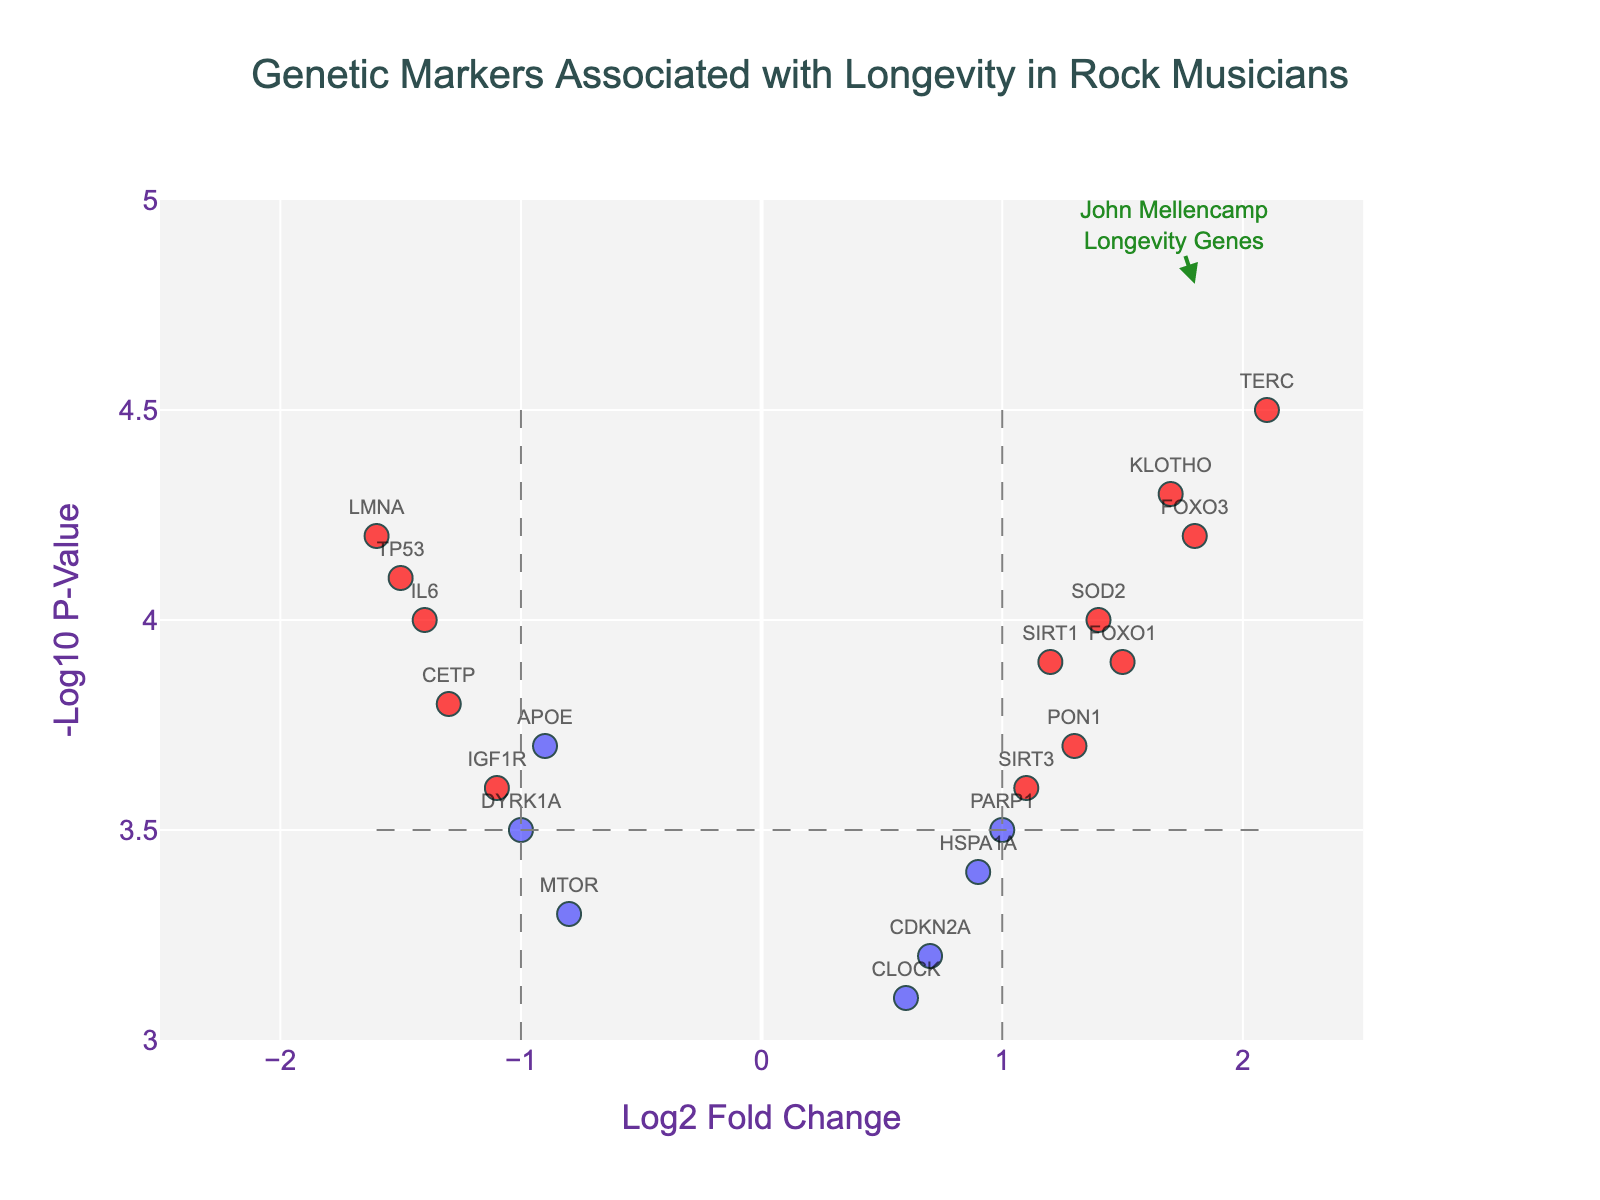How many genetic markers are plotted in the figure? Count the number of data points on the plot. Each data point represents a genetic marker, labeled with its gene name. By counting these, we find there are 20 genetic markers.
Answer: 20 Which gene has the highest -log10 p-value? Identify the data point with the highest y-axis value, as -log10 p-value is plotted on the y-axis. The gene associated with this value is TERC, which has a -log10 p-value of 4.5.
Answer: TERC Which genes are highlighted in red? To be highlighted in red, genes must have an absolute log2 fold change greater than 1 and a -log10 p-value greater than 3.5. The genes meeting these criteria are FOXO3, SIRT1, TERC, TP53, KLOTHO, SOD2, and FOXO1.
Answer: FOXO3, SIRT1, TERC, TP53, KLOTHO, SOD2, FOXO1 Which gene associated with longevity is emphasized with an annotation in the figure? Look for the additional annotation in the figure. The annotation points towards FOXO3 and highlights it as linked to John Mellencamp and longevity genes.
Answer: FOXO3 What is the log2 fold change range for the plotted genes? The log2 fold change is shown on the x-axis. The figure shows a range from approximately -1.6 to 2.1.
Answer: -1.6 to 2.1 How many genes have a -log10 p-value greater than 4.0? Count the data points above the y-axis value of 4.0. These genes are FOXO3, TERC, TP53, SOD2, KLOTHO, LMNA, IL6, FOXO1.
Answer: 8 Which gene has the lowest log2 fold change and what is its value? Identify the gene with the minimum x-axis value. This gene is LMNA, with a log2 fold change of -1.6.
Answer: LMNA, -1.6 Compare the log2 fold changes of APOE and CETP. Which one is higher? Locate both genes on the x-axis and compare their log2 fold changes. APOE has a log2 fold change of -0.9, while CETP has -1.3, so APOE is higher.
Answer: APOE What's the color representation for genes that do not meet the significance thresholds? Look at the data points that are not highlighted in red. These points are in blue, representing genes either with a log2 fold change less than the threshold of 1 (-1) or a -log10 p-value less than 3.5.
Answer: Blue What can you infer about the general trend of genes related to long-career rock musicians like John Mellencamp from this plot? By examining significant genes (highlighted in red with positive log2 fold changes), it suggests that higher expression of specific genes, such as FOXO3, TERC, SIRT1, SOD2, KLOTHO, and FOXO1, might be associated with longevity in these artists. This suggests a possible biological advantage for metabolizing stress and enhancing cellular maintenance and repair.
Answer: Positive log2 fold changes in significant genes suggest benefits 